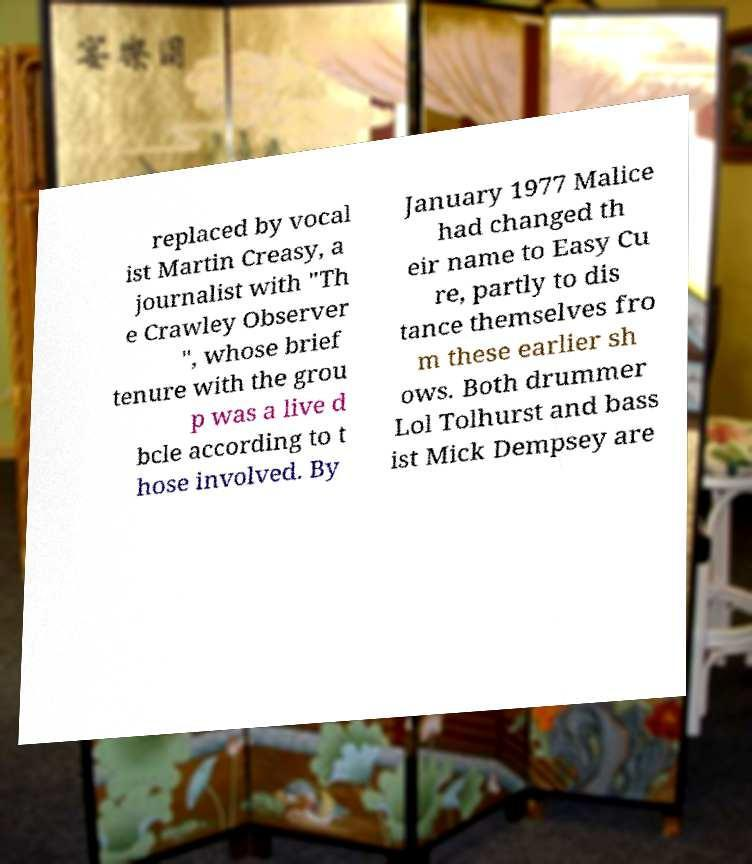What messages or text are displayed in this image? I need them in a readable, typed format. replaced by vocal ist Martin Creasy, a journalist with "Th e Crawley Observer ", whose brief tenure with the grou p was a live d bcle according to t hose involved. By January 1977 Malice had changed th eir name to Easy Cu re, partly to dis tance themselves fro m these earlier sh ows. Both drummer Lol Tolhurst and bass ist Mick Dempsey are 